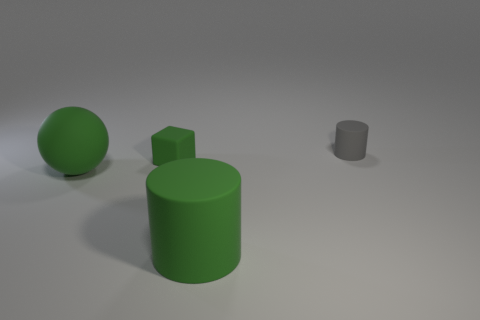Is there any other thing that is the same color as the tiny cube?
Provide a short and direct response. Yes. Do the gray thing behind the green cylinder and the small rubber block have the same size?
Offer a very short reply. Yes. What number of tiny matte blocks are behind the tiny gray cylinder on the right side of the large green sphere?
Keep it short and to the point. 0. Is there a big rubber thing that is in front of the cylinder that is left of the object right of the big green matte cylinder?
Provide a short and direct response. No. What material is the big green object that is the same shape as the small gray matte thing?
Your response must be concise. Rubber. Are the green sphere and the cylinder that is behind the big cylinder made of the same material?
Your answer should be very brief. Yes. What is the shape of the small thing on the left side of the small rubber thing behind the green rubber block?
Provide a short and direct response. Cube. How many tiny things are either blocks or yellow rubber cylinders?
Your answer should be very brief. 1. What number of other objects are the same shape as the tiny gray thing?
Ensure brevity in your answer.  1. There is a tiny gray rubber object; is its shape the same as the big green thing that is right of the green rubber sphere?
Your answer should be compact. Yes. 